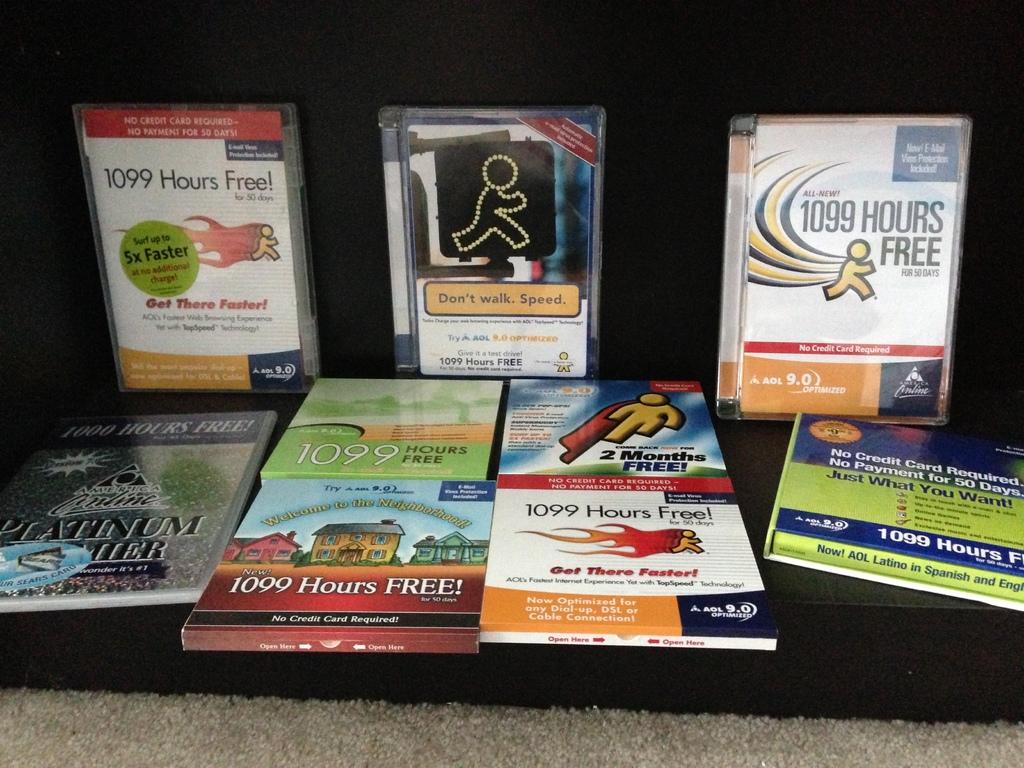How many hours free is on the top right package?
Keep it short and to the point. 1099. Who's promotions are these?
Provide a succinct answer. Aol. 